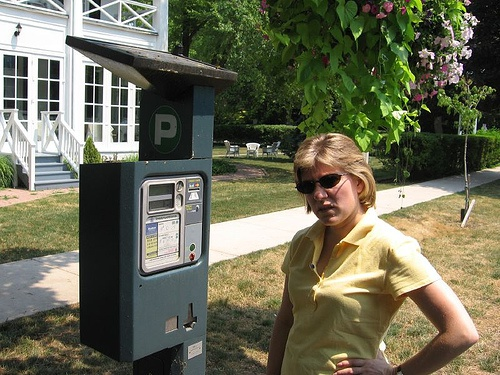Describe the objects in this image and their specific colors. I can see people in white, olive, maroon, ivory, and black tones, parking meter in white, black, gray, darkgray, and lightgray tones, chair in white, gray, black, darkgray, and darkgreen tones, chair in white, gray, darkgreen, darkgray, and black tones, and chair in white, lightgray, gray, and darkgray tones in this image. 